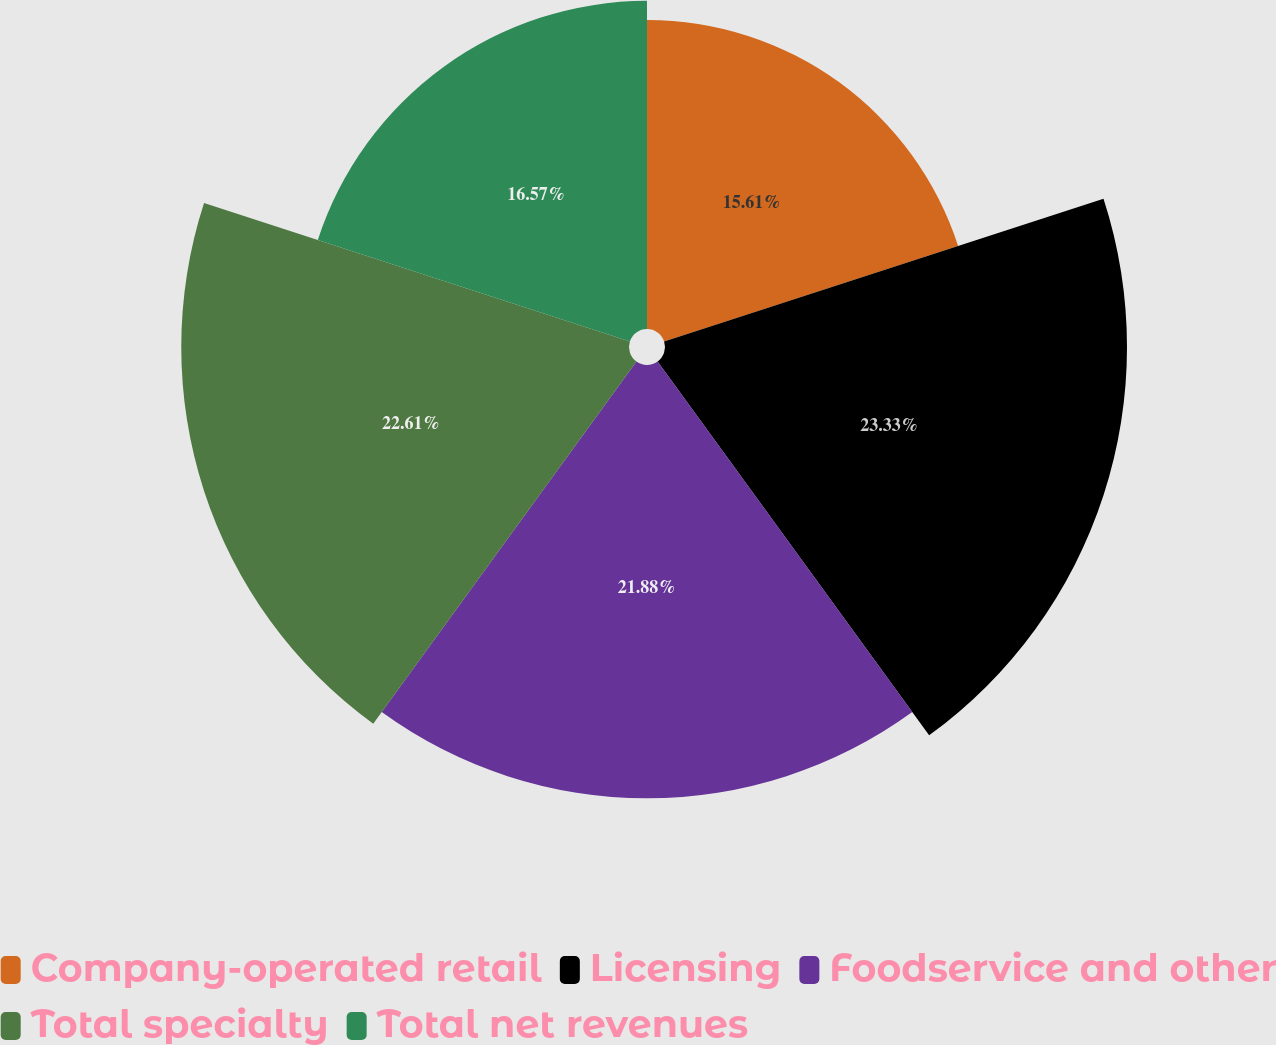Convert chart. <chart><loc_0><loc_0><loc_500><loc_500><pie_chart><fcel>Company-operated retail<fcel>Licensing<fcel>Foodservice and other<fcel>Total specialty<fcel>Total net revenues<nl><fcel>15.61%<fcel>23.33%<fcel>21.88%<fcel>22.61%<fcel>16.57%<nl></chart> 